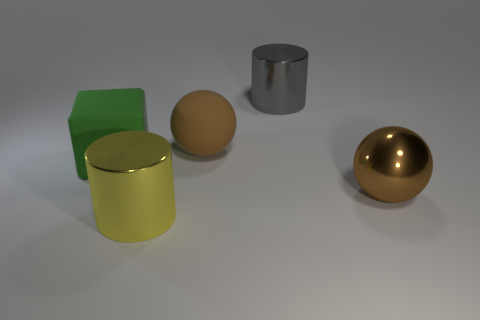Add 1 shiny cylinders. How many objects exist? 6 Subtract all cylinders. How many objects are left? 3 Subtract 0 cyan spheres. How many objects are left? 5 Subtract all large brown metallic objects. Subtract all large red matte objects. How many objects are left? 4 Add 1 rubber balls. How many rubber balls are left? 2 Add 4 yellow metal cylinders. How many yellow metal cylinders exist? 5 